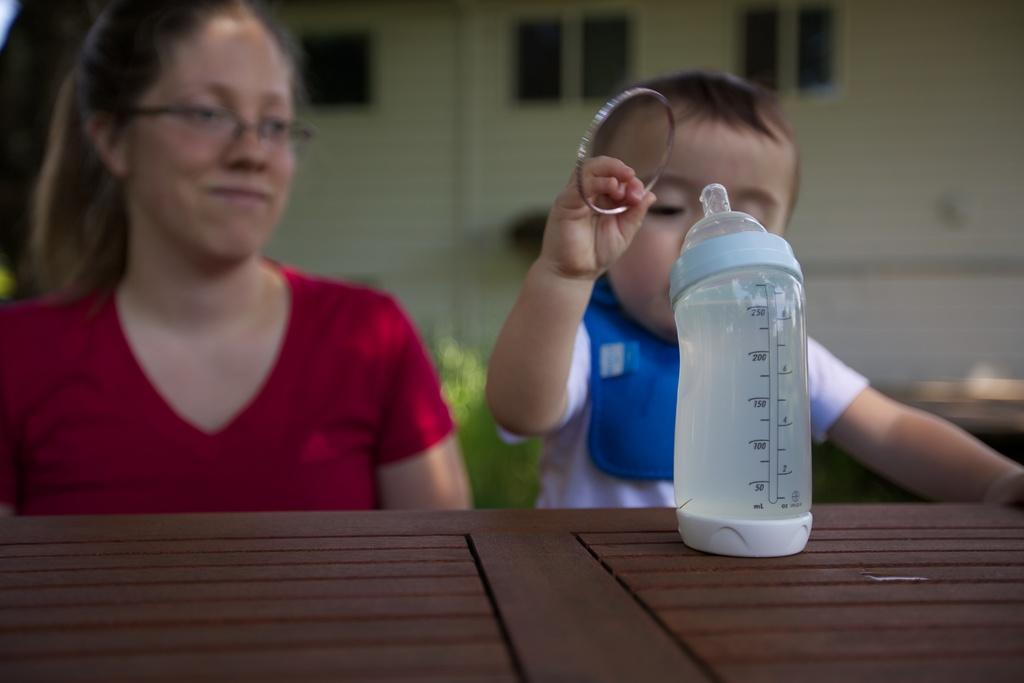What is the main subject of the image? There is a baby boy in the image. What is the baby boy holding in his hand? The baby boy is holding a steel ring in his hand. Who is on the left side of the image? There is a woman on the left side of the image. What type of table is visible in the image? There is a wooden table in the image. What is on the wooden table? A milk bottle is present on the wooden table. Is the baby boy sleeping in the image? No, the baby boy is not sleeping in the image; he is holding a steel ring in his hand. 